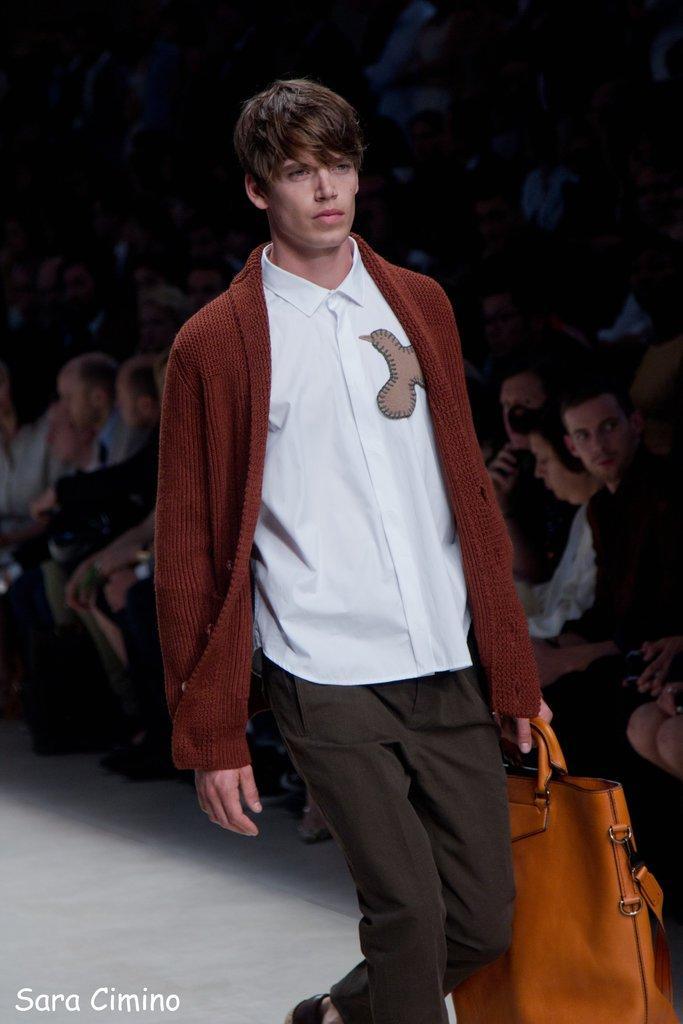In one or two sentences, can you explain what this image depicts? Here we can see a man with a bag in his hand ramp walking and beside him we can see a group of people viewing him 